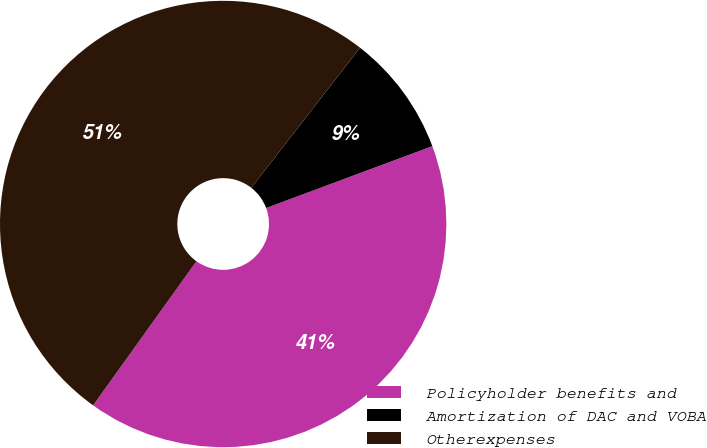<chart> <loc_0><loc_0><loc_500><loc_500><pie_chart><fcel>Policyholder benefits and<fcel>Amortization of DAC and VOBA<fcel>Otherexpenses<nl><fcel>40.57%<fcel>8.82%<fcel>50.61%<nl></chart> 